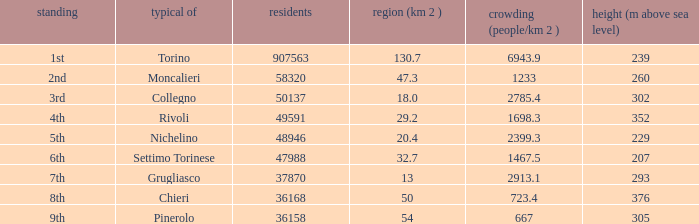What is the density of the common with an area of 20.4 km^2? 2399.3. 